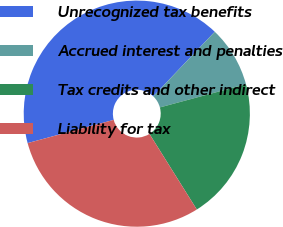Convert chart. <chart><loc_0><loc_0><loc_500><loc_500><pie_chart><fcel>Unrecognized tax benefits<fcel>Accrued interest and penalties<fcel>Tax credits and other indirect<fcel>Liability for tax<nl><fcel>41.3%<fcel>8.7%<fcel>20.29%<fcel>29.71%<nl></chart> 